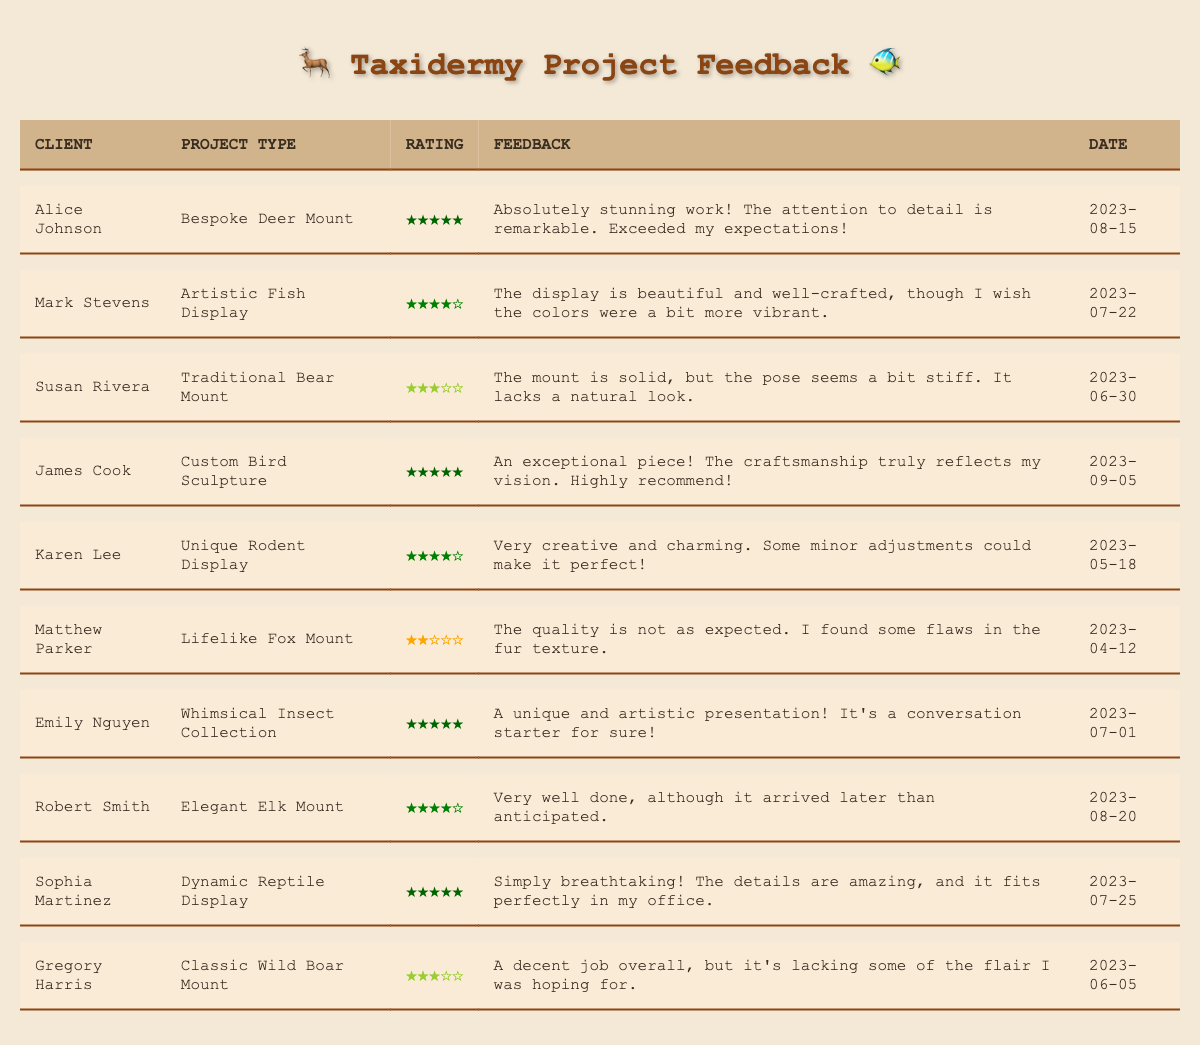What project did Sophia Martinez have done? Sophia Martinez had a Dynamic Reptile Display project completed, as seen in the "Project Type" column of her row.
Answer: Dynamic Reptile Display Who received the highest satisfaction rating? Alice Johnson and James Cook both received a satisfaction rating of 5, which is the highest rating on the table.
Answer: Alice Johnson and James Cook What is the overall average satisfaction rating from the clients in the table? To find the average satisfaction rating, add all ratings (5 + 4 + 3 + 5 + 4 + 2 + 5 + 4 + 5 + 3 = 44) and divide by the number of clients (10). So, 44 / 10 = 4.4.
Answer: 4.4 Did any clients express dissatisfaction with their projects? Yes, Matthew Parker expressed dissatisfaction with his Lifelike Fox Mount project, giving it a rating of 2 and mentioning flaws in the fur texture in his feedback.
Answer: Yes What percentage of clients rated their satisfaction as 4 or above? There are 7 clients (Alice Johnson, Mark Stevens, James Cook, Emily Nguyen, Robert Smith, Karen Lee, Sophia Martinez) with ratings of 4 or higher out of 10 total clients. The percentage is (7/10) * 100 = 70%.
Answer: 70% Which client wished for certain aspects to be improved? Susan Rivera wished for improvement on the pose of her Traditional Bear Mount project since she mentioned it seemed stiff and lacked a natural look in her feedback.
Answer: Susan Rivera How many projects received a satisfaction rating of 3 or lower? The projects that received a satisfaction rating of 3 or lower are 3 (Susan Rivera, Matthew Parker, and Gregory Harris) out of 10.
Answer: 3 What is the feedback trend for projects rated 5? Clients who rated projects 5 provided enthusiastic and positive feedback, highlighting craftsmanship, attention to detail, and uniqueness, all expressing high satisfaction levels and recommending the service.
Answer: Positive and enthusiastic feedback 